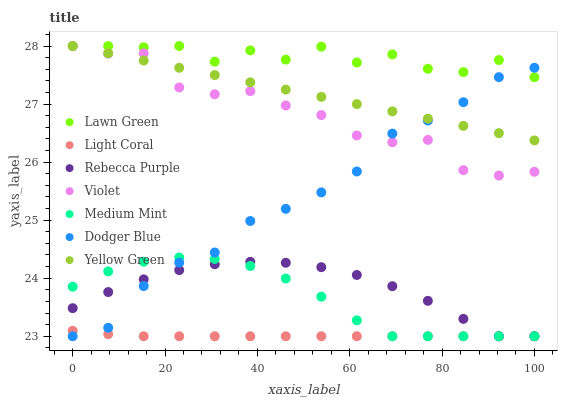Does Light Coral have the minimum area under the curve?
Answer yes or no. Yes. Does Lawn Green have the maximum area under the curve?
Answer yes or no. Yes. Does Yellow Green have the minimum area under the curve?
Answer yes or no. No. Does Yellow Green have the maximum area under the curve?
Answer yes or no. No. Is Yellow Green the smoothest?
Answer yes or no. Yes. Is Lawn Green the roughest?
Answer yes or no. Yes. Is Lawn Green the smoothest?
Answer yes or no. No. Is Yellow Green the roughest?
Answer yes or no. No. Does Medium Mint have the lowest value?
Answer yes or no. Yes. Does Yellow Green have the lowest value?
Answer yes or no. No. Does Violet have the highest value?
Answer yes or no. Yes. Does Light Coral have the highest value?
Answer yes or no. No. Is Rebecca Purple less than Violet?
Answer yes or no. Yes. Is Lawn Green greater than Medium Mint?
Answer yes or no. Yes. Does Dodger Blue intersect Yellow Green?
Answer yes or no. Yes. Is Dodger Blue less than Yellow Green?
Answer yes or no. No. Is Dodger Blue greater than Yellow Green?
Answer yes or no. No. Does Rebecca Purple intersect Violet?
Answer yes or no. No. 